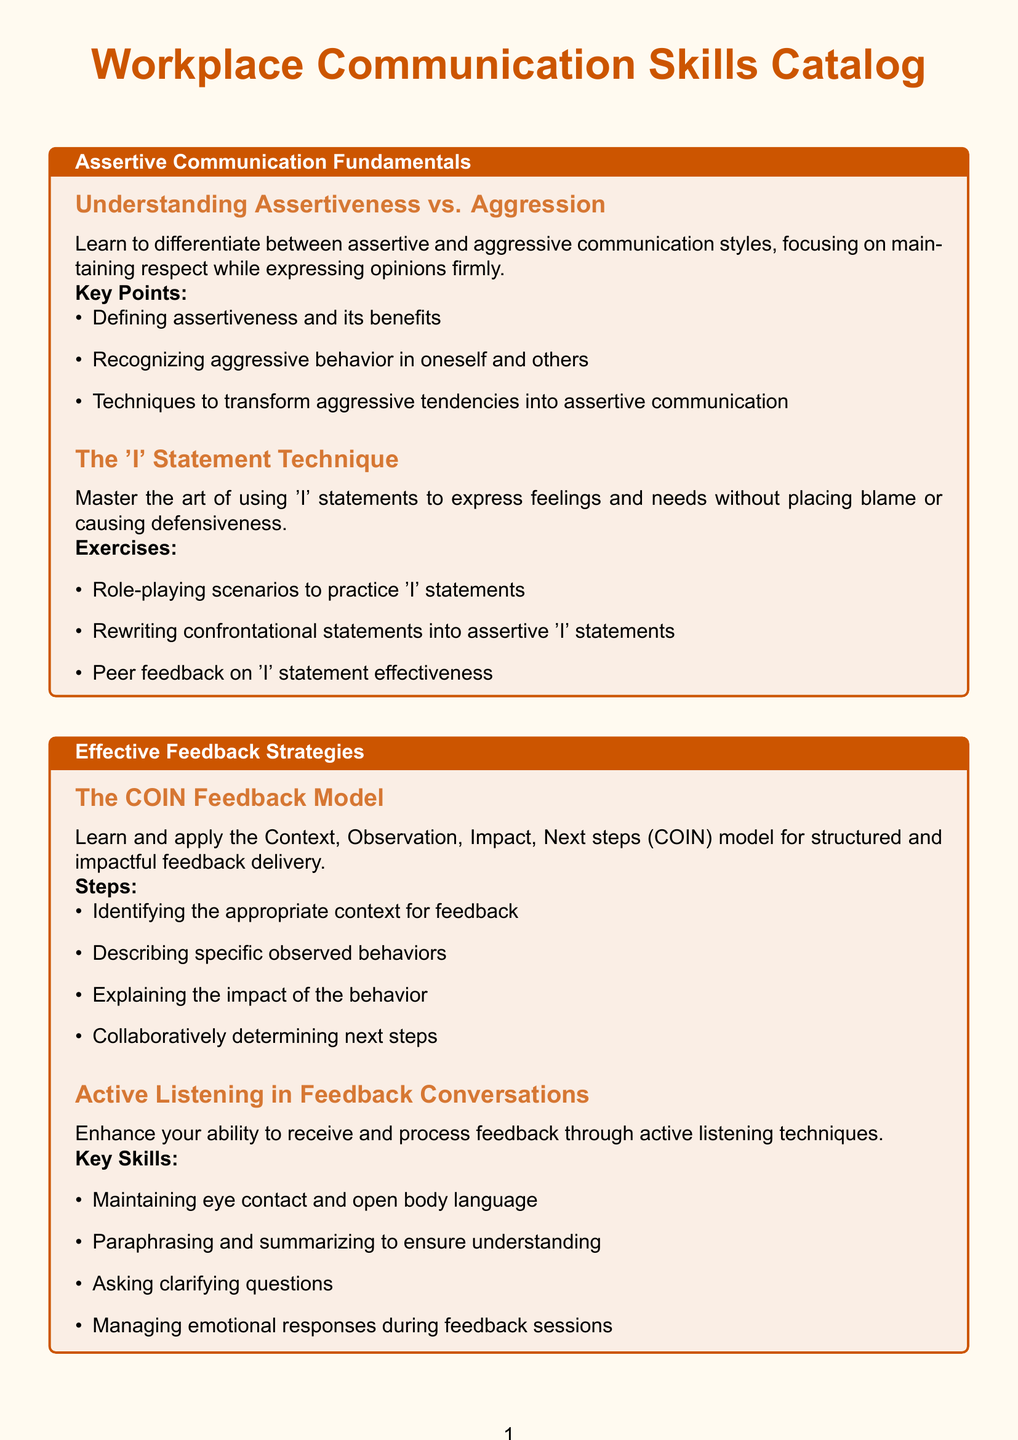what is the title of the first section? The title of the first section is prominently displayed at the beginning of that section, which is "Assertive Communication Fundamentals."
Answer: Assertive Communication Fundamentals how many subsections are there under "Effective Feedback Strategies"? The number of subsections is counted directly from the document under that section, which lists two subsections.
Answer: 2 what is one key point of the "Understanding Assertiveness vs. Aggression" subsection? Key points are listed in bullet format; one of them is "Defining assertiveness and its benefits."
Answer: Defining assertiveness and its benefits name one technique to transform aggressive tendencies into assertive communication. Techniques are listed under key points; one example is provided in the document.
Answer: Techniques to transform aggressive tendencies into assertive communication what are the components of "Emotional Intelligence in the Workplace"? The components are defined and listed as key components in the subsection description.
Answer: Self-awareness, Self-regulation, Motivation, Empathy, Social skills how does the COIN feedback model outline feedback delivery? The steps of the COIN model are explicitly described in the relevant subsection of the document.
Answer: Context, Observation, Impact, Next steps what is one strategy from the "De-escalation Strategies for Heated Discussions"? One strategy is explicitly mentioned in the document as a method for handling heated discussions.
Answer: Using empathetic statements to acknowledge emotions which digital communication technique involves managing interruptions? The technique is part of the tips provided for assertive communication in video conferences.
Answer: Managing interruptions assertively 